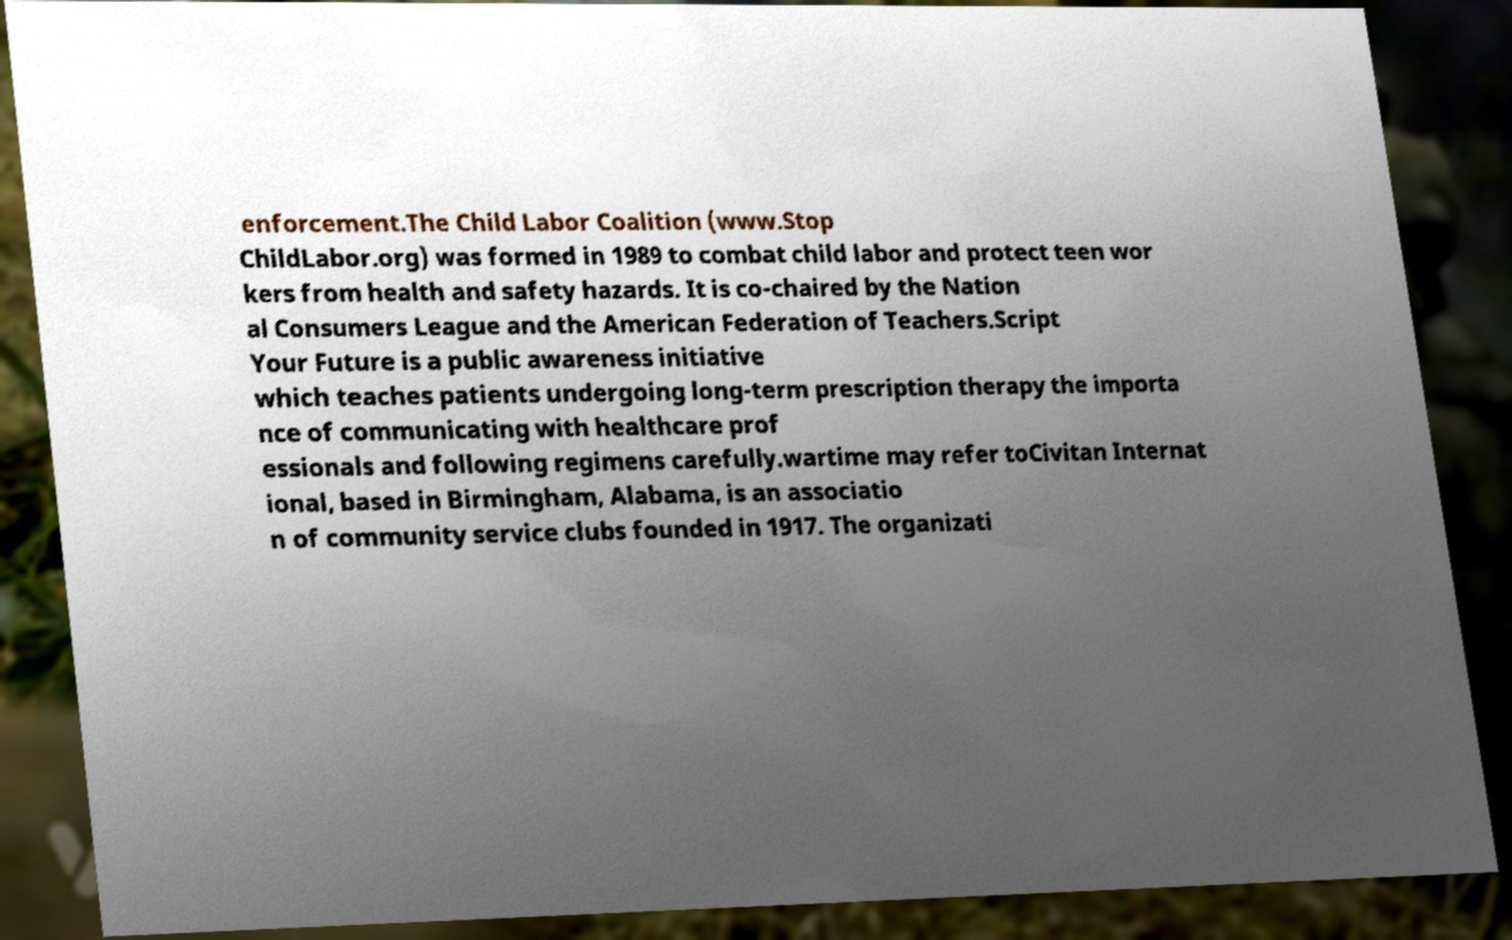For documentation purposes, I need the text within this image transcribed. Could you provide that? enforcement.The Child Labor Coalition (www.Stop ChildLabor.org) was formed in 1989 to combat child labor and protect teen wor kers from health and safety hazards. It is co-chaired by the Nation al Consumers League and the American Federation of Teachers.Script Your Future is a public awareness initiative which teaches patients undergoing long-term prescription therapy the importa nce of communicating with healthcare prof essionals and following regimens carefully.wartime may refer toCivitan Internat ional, based in Birmingham, Alabama, is an associatio n of community service clubs founded in 1917. The organizati 